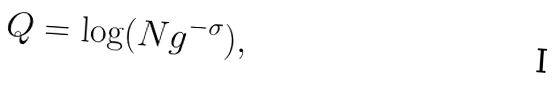<formula> <loc_0><loc_0><loc_500><loc_500>Q = \log ( N g ^ { - \sigma } ) ,</formula> 